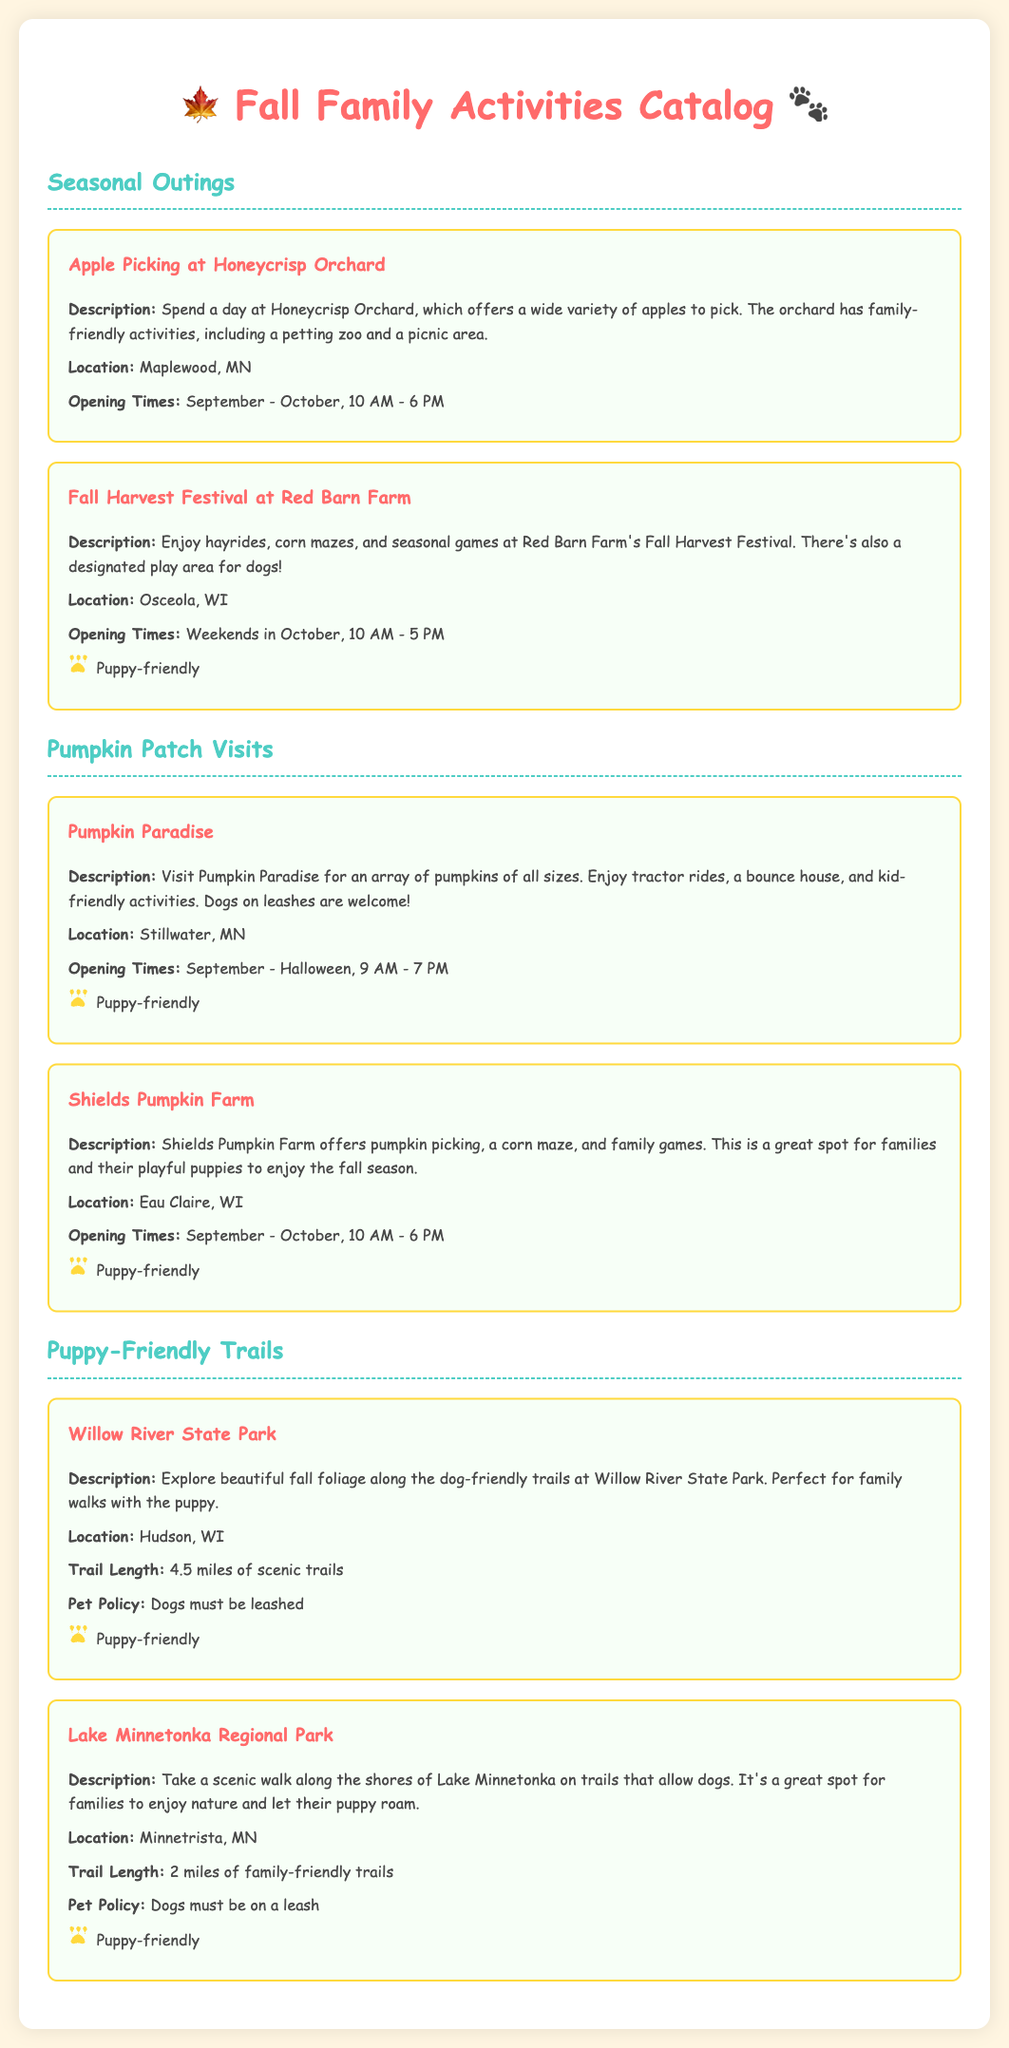What activities are available at Honeycrisp Orchard? The document states that Honeycrisp Orchard offers apple picking, a petting zoo, and a picnic area.
Answer: Apple picking, petting zoo, picnic area What is the location of Pumpkin Paradise? The location is specifically mentioned in the document for Pumpkin Paradise as Stillwater, MN.
Answer: Stillwater, MN What are the opening times for Shields Pumpkin Farm? The document provides the opening times for Shields Pumpkin Farm as September to October from 10 AM to 6 PM.
Answer: September - October, 10 AM - 6 PM How long is the trail at Willow River State Park? The document indicates that the trail length at Willow River State Park is 4.5 miles.
Answer: 4.5 miles Which location mentions a designated play area for dogs? The document highlights that Red Barn Farm's Fall Harvest Festival includes a designated play area for dogs.
Answer: Red Barn Farm What type of activities can families do at Shields Pumpkin Farm? The document mentions pumpkin picking, a corn maze, and family games as activities at Shields Pumpkin Farm.
Answer: Pumpkin picking, corn maze, family games How many puppy-friendly activities are listed in the catalog? The document mentions three activity categories that highlight puppy-friendly outings.
Answer: Three What is the pet policy at Lake Minnetonka Regional Park? The document states that the pet policy at Lake Minnetonka Regional Park requires dogs to be on a leash.
Answer: Dogs must be on a leash 